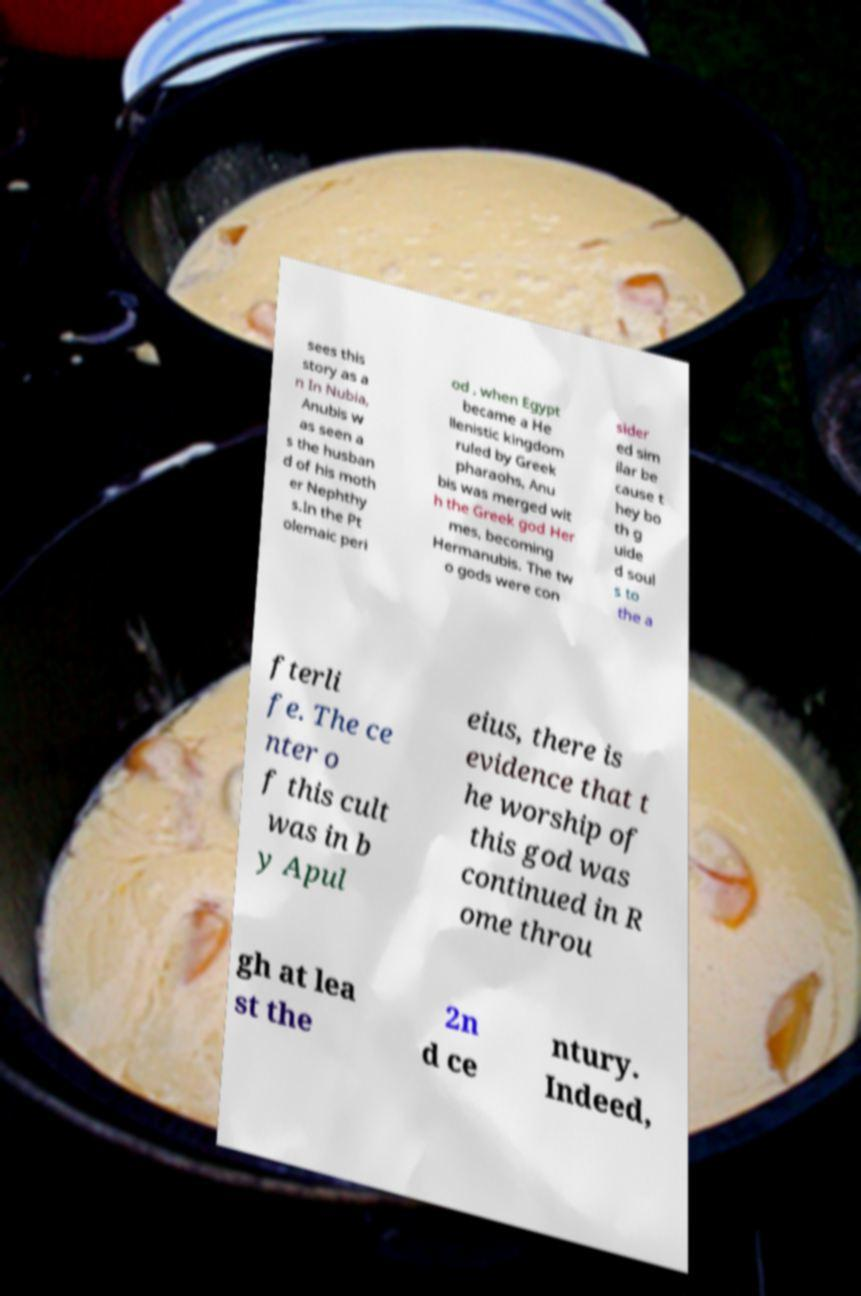I need the written content from this picture converted into text. Can you do that? sees this story as a n In Nubia, Anubis w as seen a s the husban d of his moth er Nephthy s.In the Pt olemaic peri od , when Egypt became a He llenistic kingdom ruled by Greek pharaohs, Anu bis was merged wit h the Greek god Her mes, becoming Hermanubis. The tw o gods were con sider ed sim ilar be cause t hey bo th g uide d soul s to the a fterli fe. The ce nter o f this cult was in b y Apul eius, there is evidence that t he worship of this god was continued in R ome throu gh at lea st the 2n d ce ntury. Indeed, 